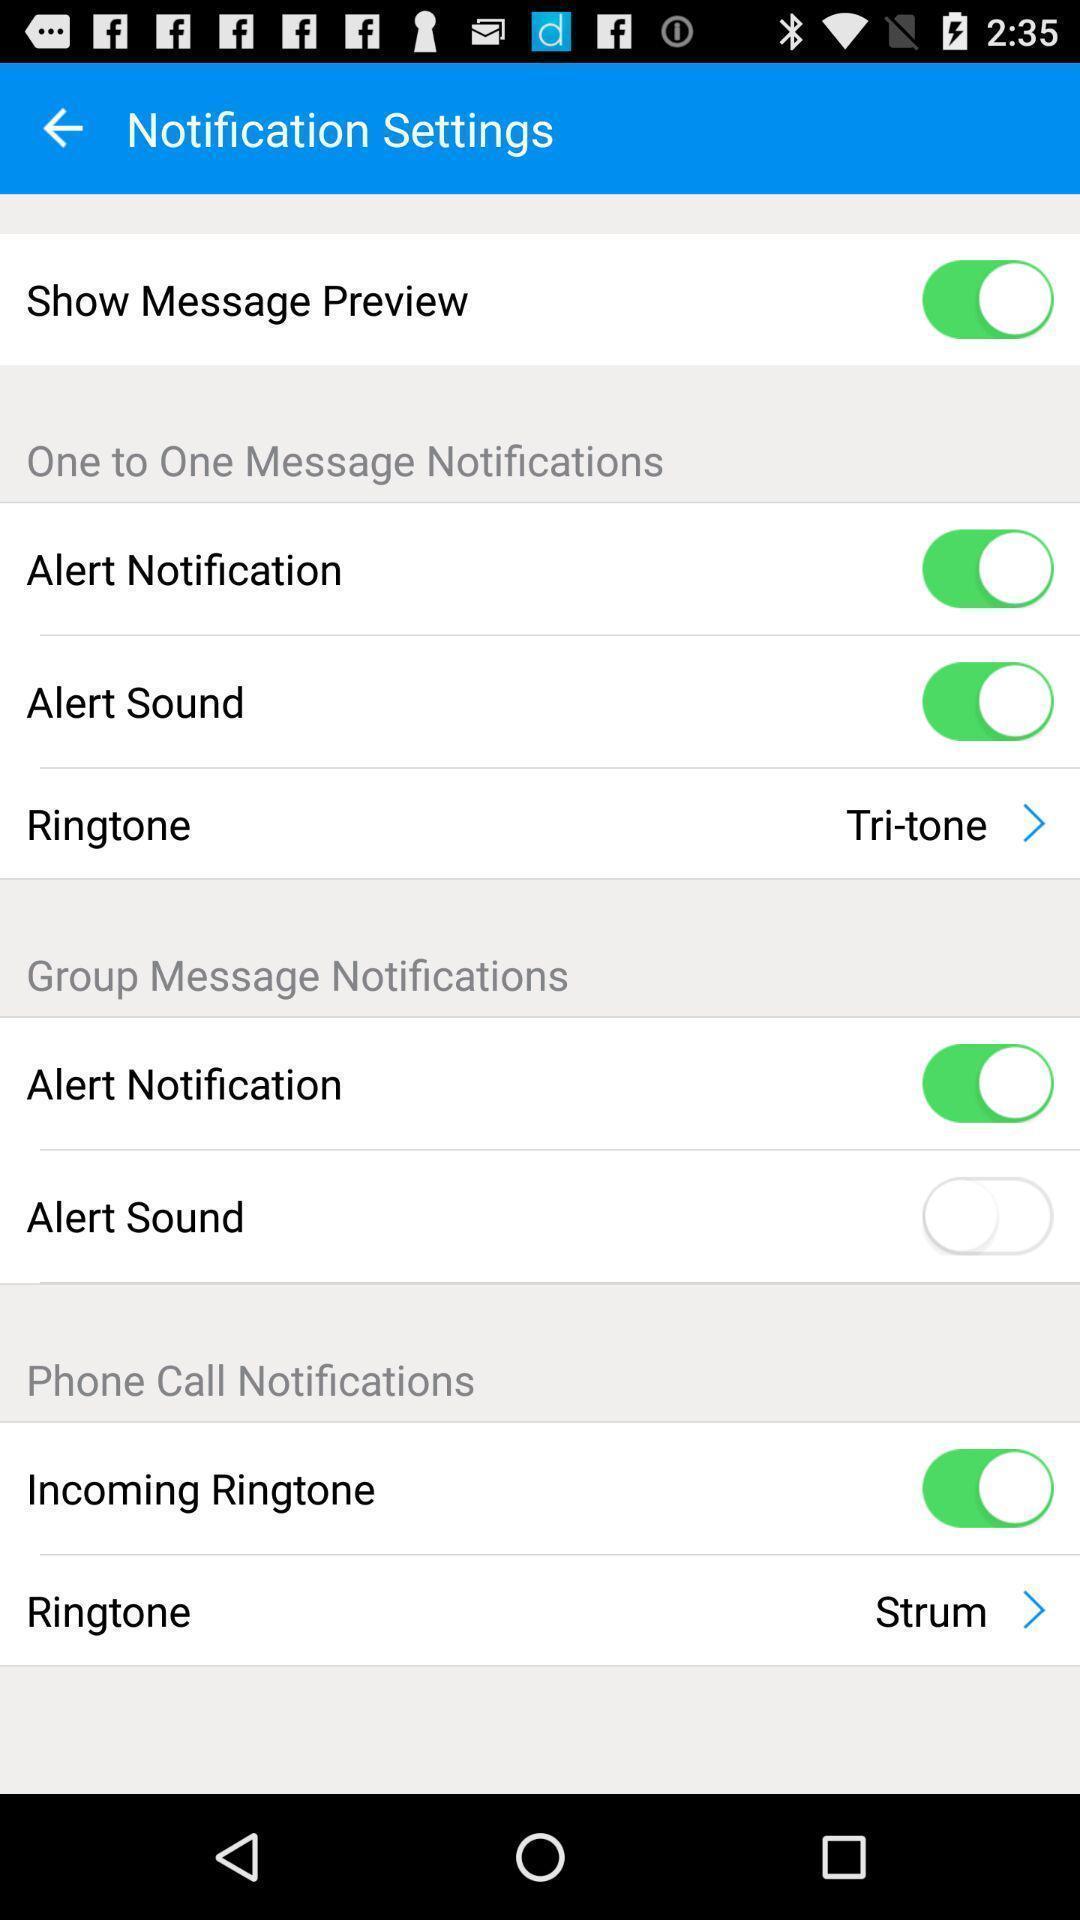Tell me about the visual elements in this screen capture. Screen shows list of notification settings. 